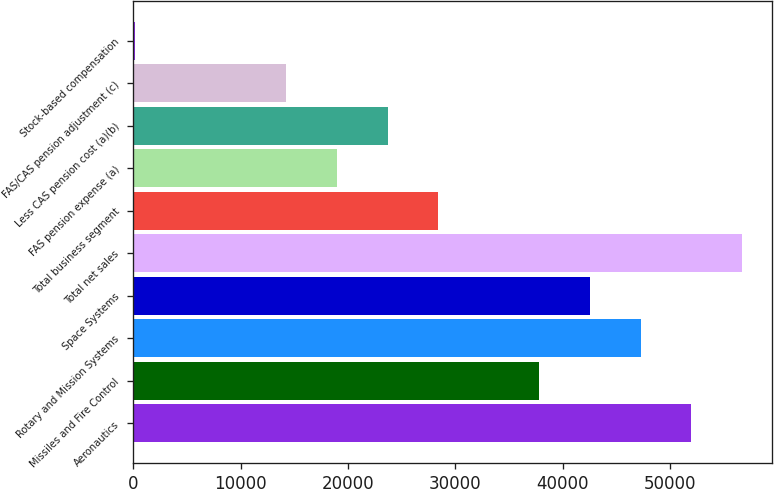Convert chart to OTSL. <chart><loc_0><loc_0><loc_500><loc_500><bar_chart><fcel>Aeronautics<fcel>Missiles and Fire Control<fcel>Rotary and Mission Systems<fcel>Space Systems<fcel>Total net sales<fcel>Total business segment<fcel>FAS pension expense (a)<fcel>Less CAS pension cost (a)(b)<fcel>FAS/CAS pension adjustment (c)<fcel>Stock-based compensation<nl><fcel>51957.9<fcel>37828.2<fcel>47248<fcel>42538.1<fcel>56667.8<fcel>28408.4<fcel>18988.6<fcel>23698.5<fcel>14278.7<fcel>149<nl></chart> 